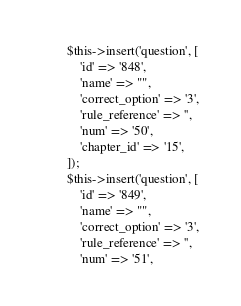Convert code to text. <code><loc_0><loc_0><loc_500><loc_500><_PHP_>        $this->insert('question', [
            'id' => '848',
            'name' => "",
            'correct_option' => '3',
            'rule_reference' => '',
            'num' => '50',
            'chapter_id' => '15',
        ]);
        $this->insert('question', [
            'id' => '849',
            'name' => "",
            'correct_option' => '3',
            'rule_reference' => '',
            'num' => '51',</code> 